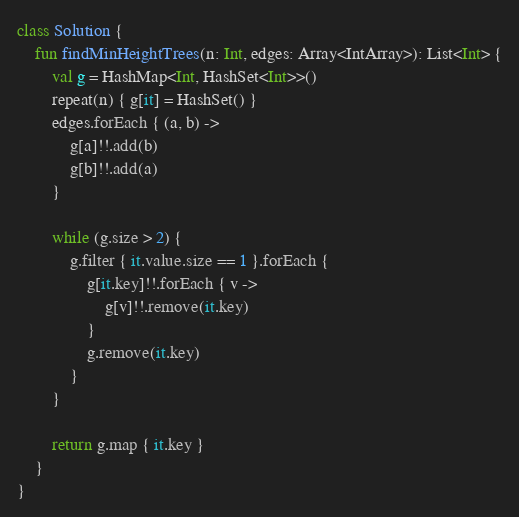<code> <loc_0><loc_0><loc_500><loc_500><_Kotlin_>class Solution {
    fun findMinHeightTrees(n: Int, edges: Array<IntArray>): List<Int> {
        val g = HashMap<Int, HashSet<Int>>()
        repeat(n) { g[it] = HashSet() }
        edges.forEach { (a, b) ->
            g[a]!!.add(b)
            g[b]!!.add(a)
        }

        while (g.size > 2) {
            g.filter { it.value.size == 1 }.forEach {
                g[it.key]!!.forEach { v ->
                    g[v]!!.remove(it.key)
                }
                g.remove(it.key)
            }
        }

        return g.map { it.key }
    }
}
</code> 